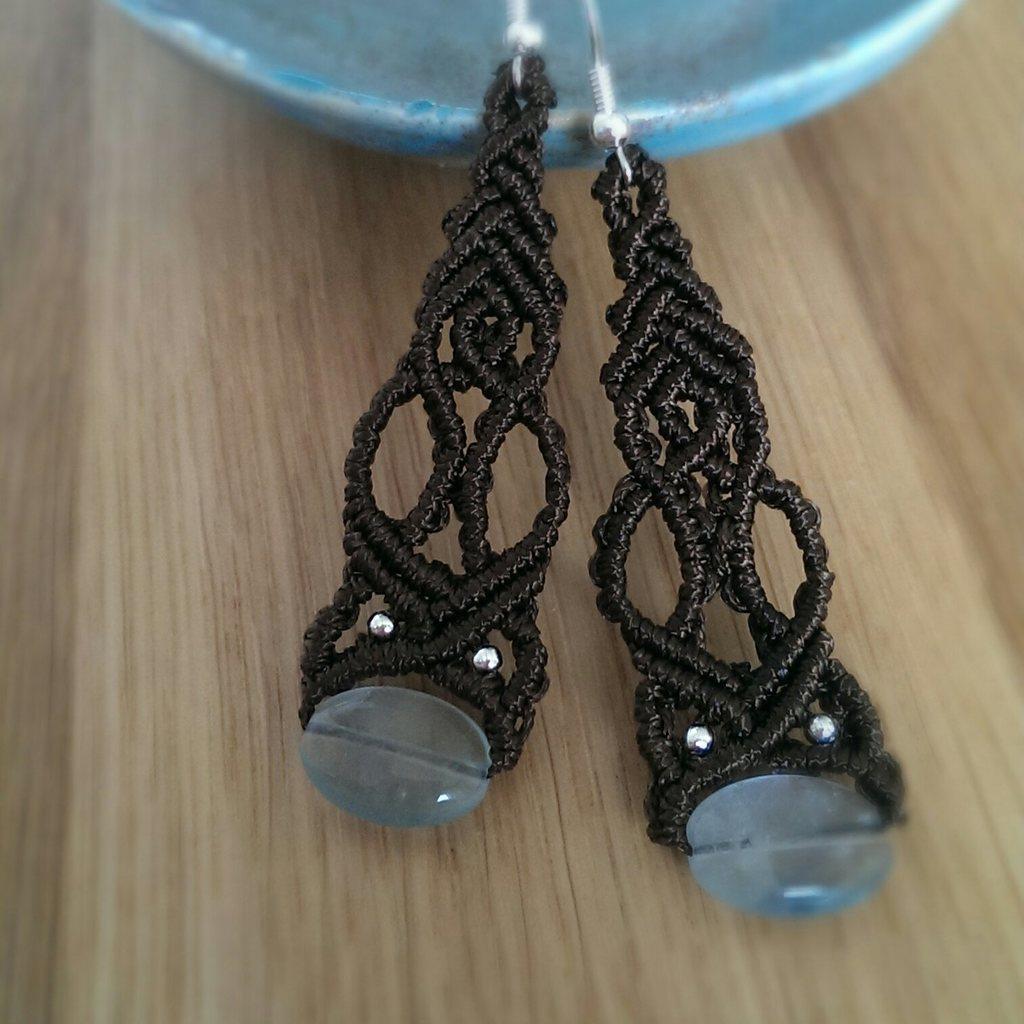In one or two sentences, can you explain what this image depicts? In this picture we can see earrings on a wooden platform. At the top we can see a blue color object. 